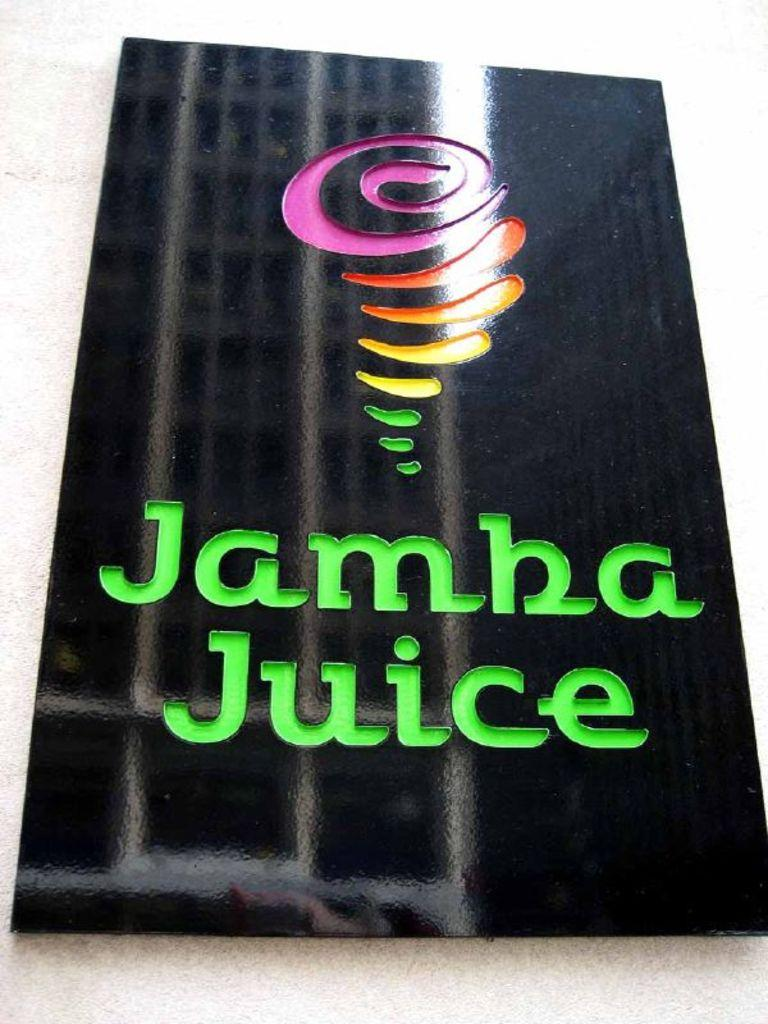What is on the wall in the image? There is a frame on the wall in the image. What type of leaf is hanging from the toy in the image? There is no leaf or toy present in the image; only a frame on the wall is visible. 